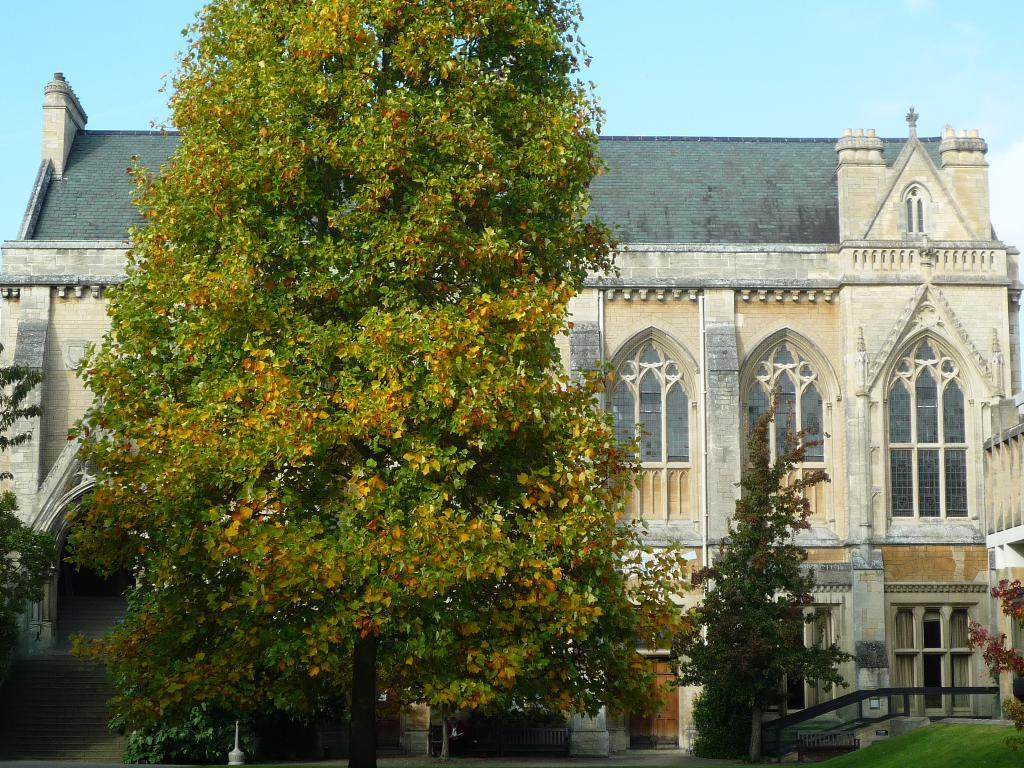What type of vegetation is visible in the front of the image? There are trees in the front of the image. What is covering the ground in the image? There is grass on the ground in the image. What can be seen in the center of the image? There is a railing in the center of the image. What type of structure is present in the image? There is a building in the image. What type of cracker is being played in the background of the image? There is no mention of music or any type of cracker in the image; it primarily features trees, grass, a railing, and a building. 